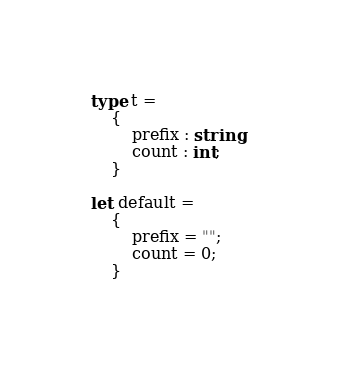Convert code to text. <code><loc_0><loc_0><loc_500><loc_500><_OCaml_>type t =
    {
        prefix : string;
        count : int;
    }

let default =
    {
        prefix = "";
        count = 0;
    }
</code> 